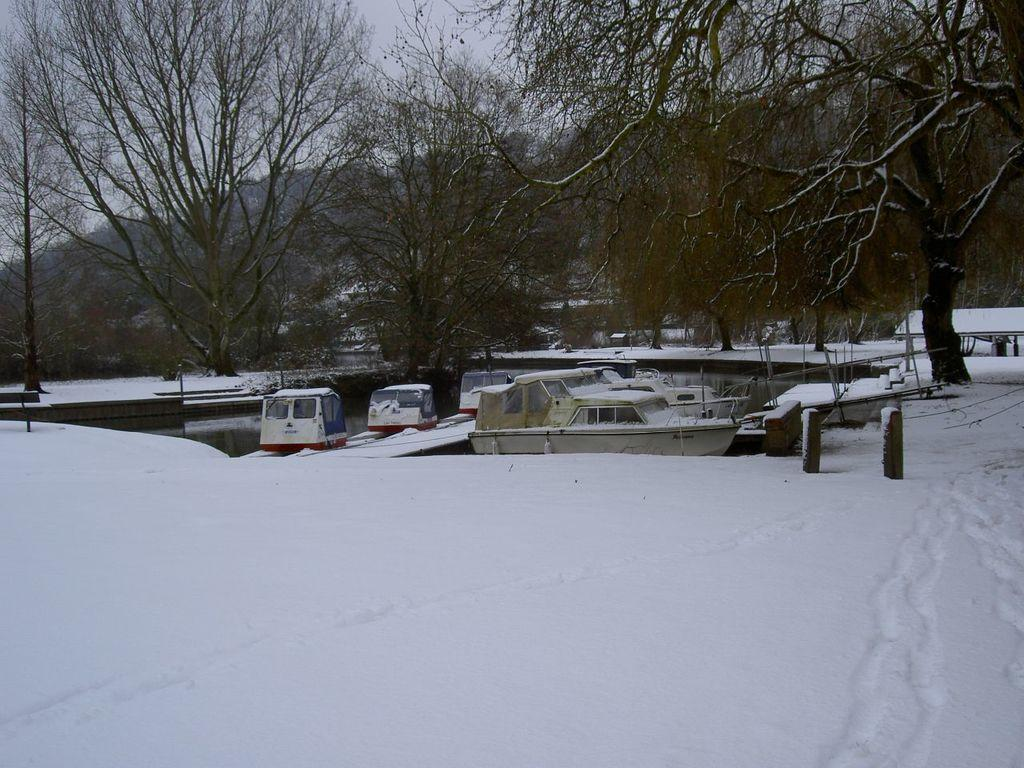What type of weather is depicted in the image? There is snow in the image, indicating cold weather. What is the body of water in the image? There is water visible in the image, and boats are present, suggesting it is a lake or river. What type of vegetation can be seen in the image? There are trees in the image. What is visible in the sky in the image? The sky is visible in the image. Can you tell me how many clovers are growing in the snow in the image? There are no clovers present in the image; it features snow, water, boats, trees, and a visible sky. What type of muscle is being exercised by the boats in the image? There are no muscles present in the image; it features snow, water, boats, trees, and a visible sky. 